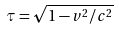Convert formula to latex. <formula><loc_0><loc_0><loc_500><loc_500>\tau = \sqrt { 1 - v ^ { 2 } / c ^ { 2 } }</formula> 